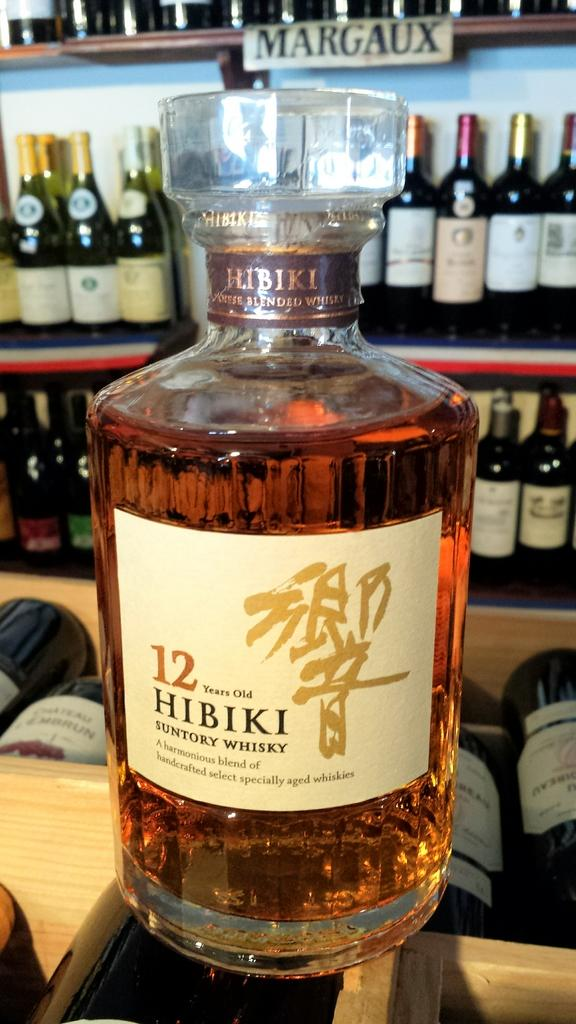<image>
Describe the image concisely. A bottle of 12 Hibiki Suntory Whisky being displayed. 